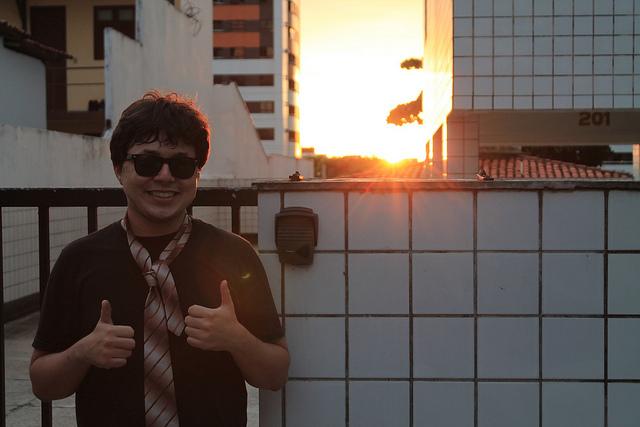What is the man wearing on his left wrist?
Write a very short answer. Nothing. Is the sun bright?
Short answer required. Yes. What does this gesture mean?
Be succinct. Good. Is the man wearing sunglasses or eyeglasses?
Quick response, please. Sunglasses. What three numbers are on the building in the background?
Give a very brief answer. 201. What type of necklace is the man wearing?
Be succinct. Tie. 